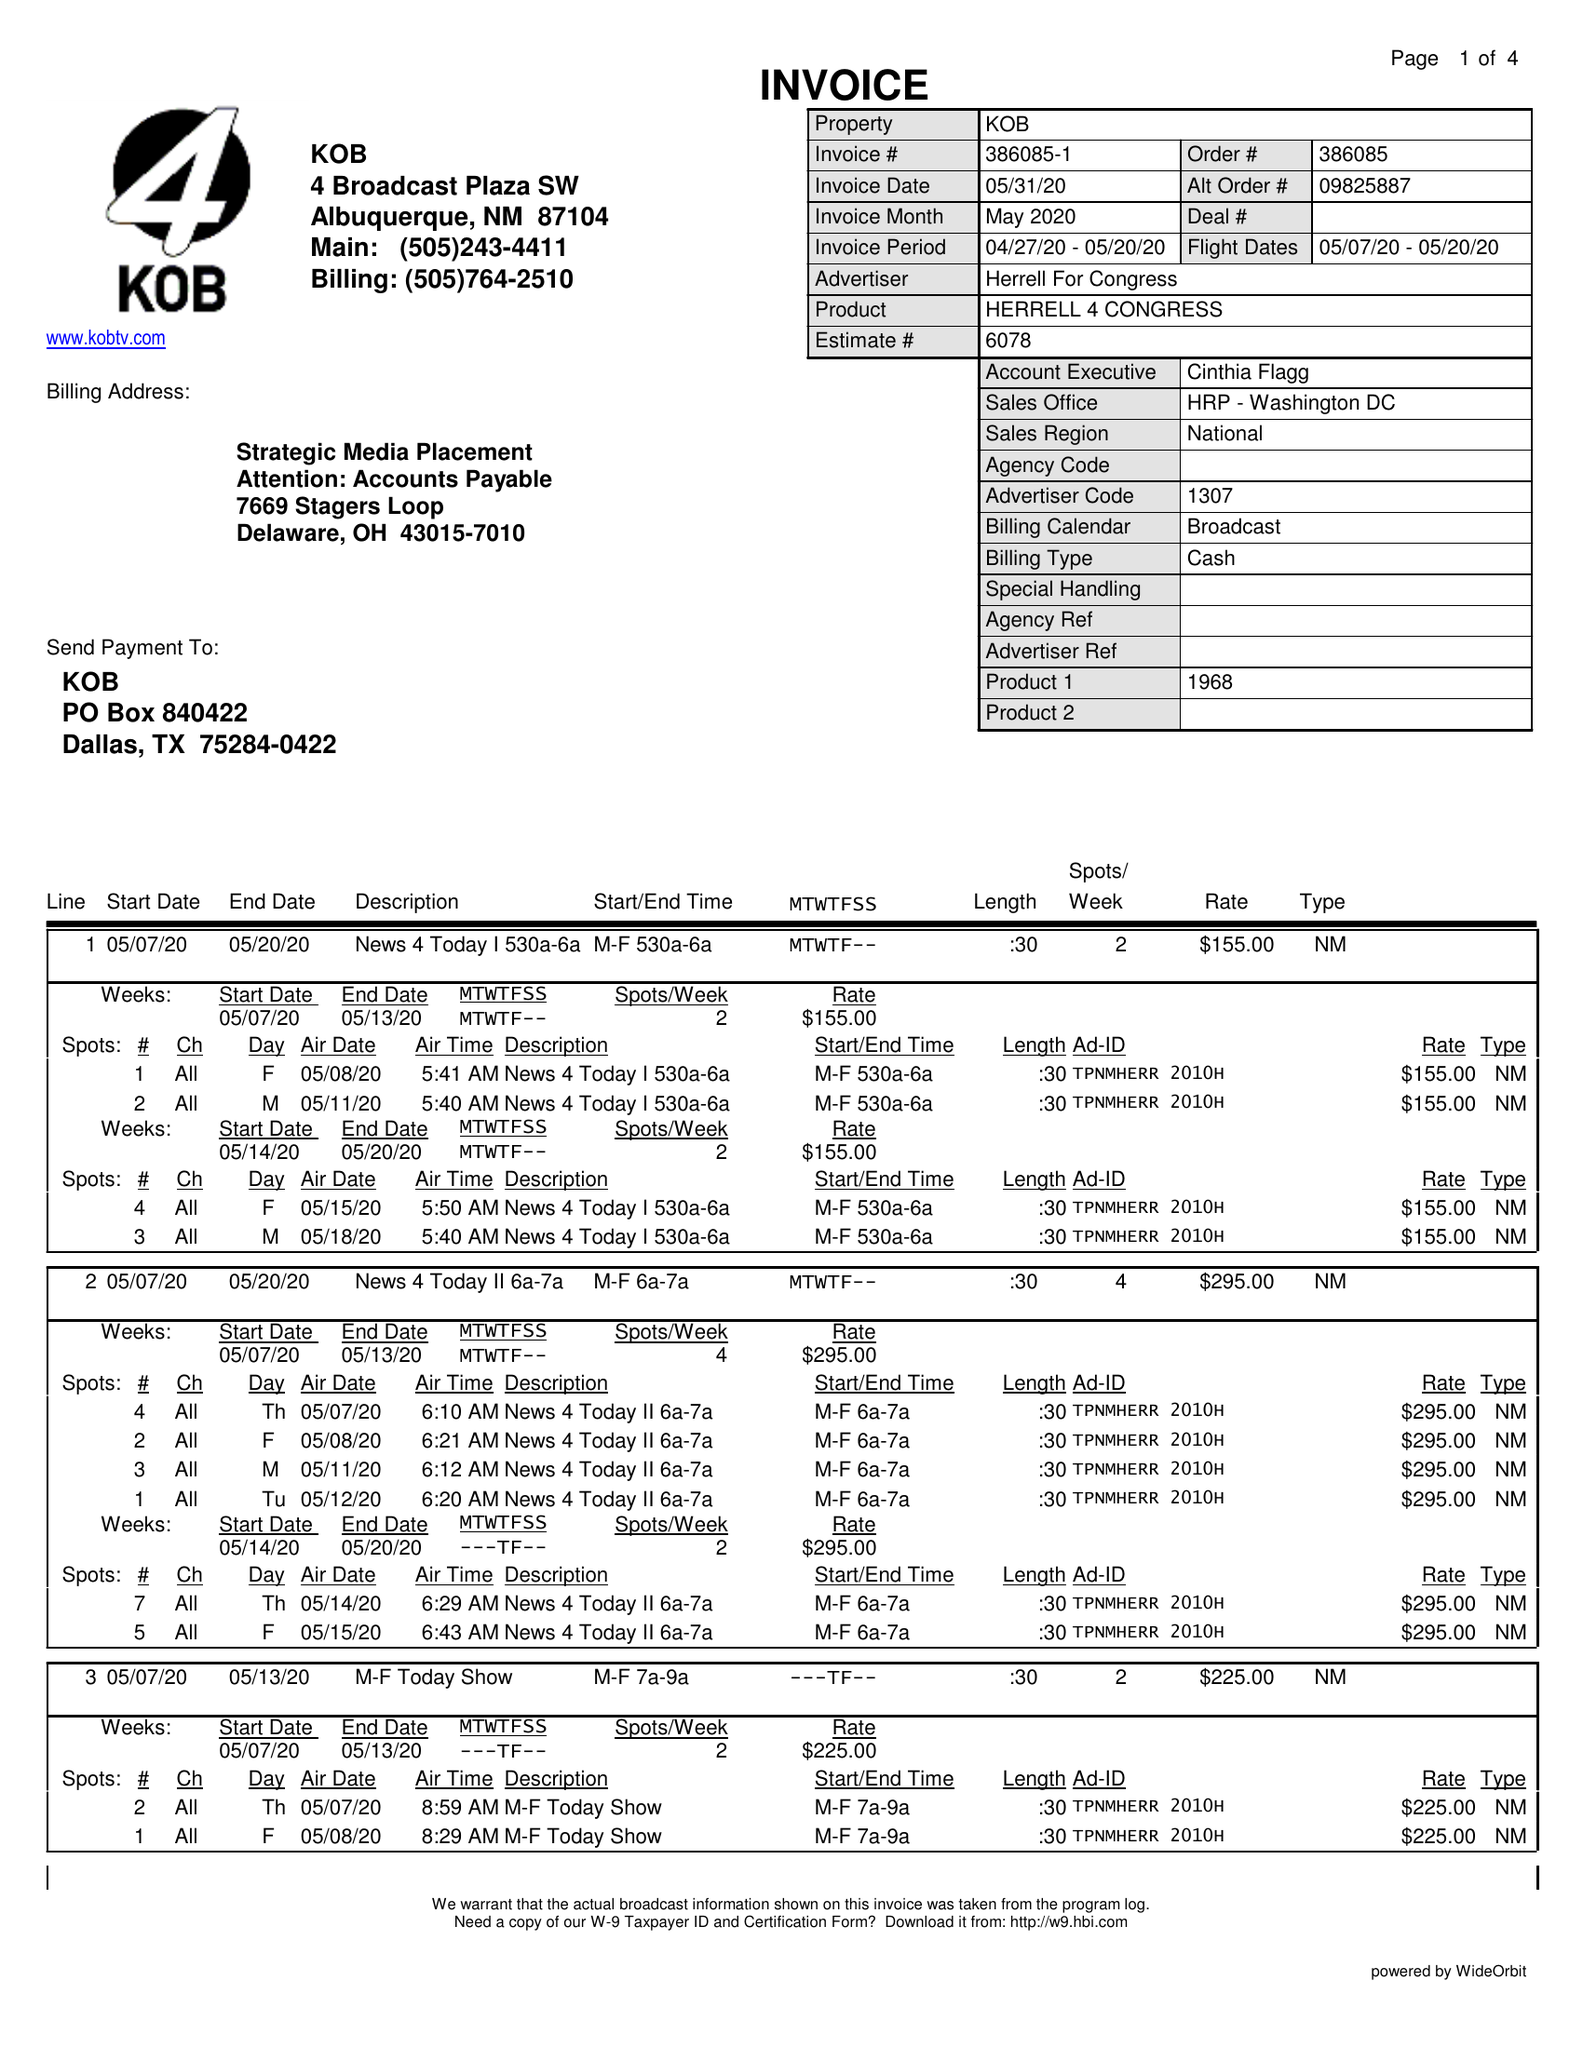What is the value for the advertiser?
Answer the question using a single word or phrase. HERRELL FOR CONGRESS 